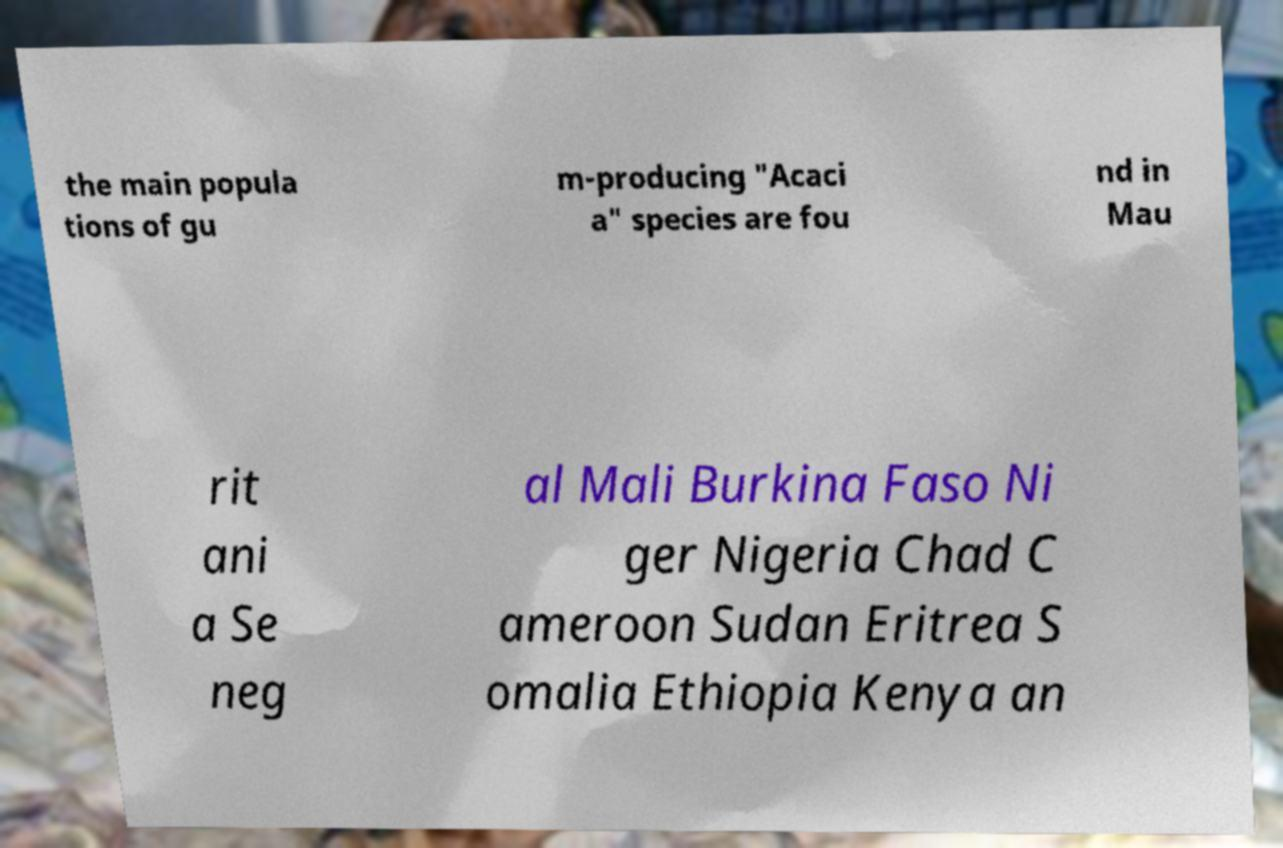For documentation purposes, I need the text within this image transcribed. Could you provide that? the main popula tions of gu m-producing "Acaci a" species are fou nd in Mau rit ani a Se neg al Mali Burkina Faso Ni ger Nigeria Chad C ameroon Sudan Eritrea S omalia Ethiopia Kenya an 